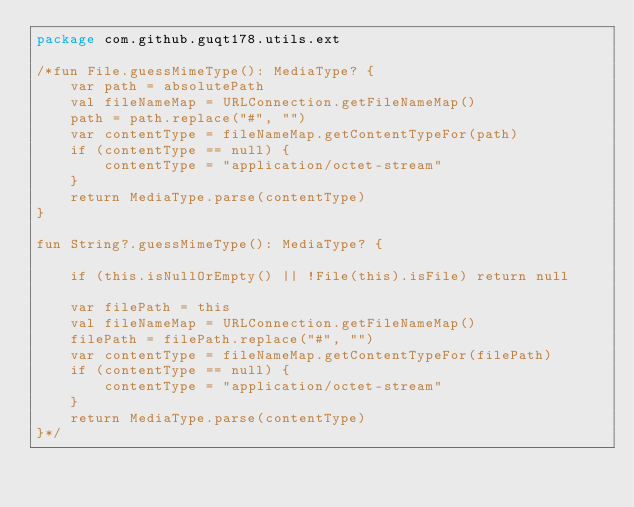<code> <loc_0><loc_0><loc_500><loc_500><_Kotlin_>package com.github.guqt178.utils.ext

/*fun File.guessMimeType(): MediaType? {
    var path = absolutePath
    val fileNameMap = URLConnection.getFileNameMap()
    path = path.replace("#", "")
    var contentType = fileNameMap.getContentTypeFor(path)
    if (contentType == null) {
        contentType = "application/octet-stream"
    }
    return MediaType.parse(contentType)
}

fun String?.guessMimeType(): MediaType? {

    if (this.isNullOrEmpty() || !File(this).isFile) return null

    var filePath = this
    val fileNameMap = URLConnection.getFileNameMap()
    filePath = filePath.replace("#", "")
    var contentType = fileNameMap.getContentTypeFor(filePath)
    if (contentType == null) {
        contentType = "application/octet-stream"
    }
    return MediaType.parse(contentType)
}*/
</code> 